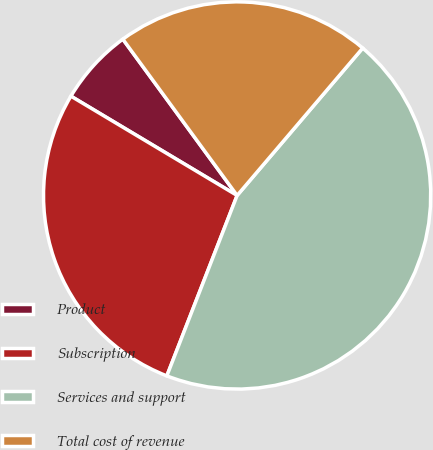Convert chart to OTSL. <chart><loc_0><loc_0><loc_500><loc_500><pie_chart><fcel>Product<fcel>Subscription<fcel>Services and support<fcel>Total cost of revenue<nl><fcel>6.38%<fcel>27.66%<fcel>44.68%<fcel>21.28%<nl></chart> 